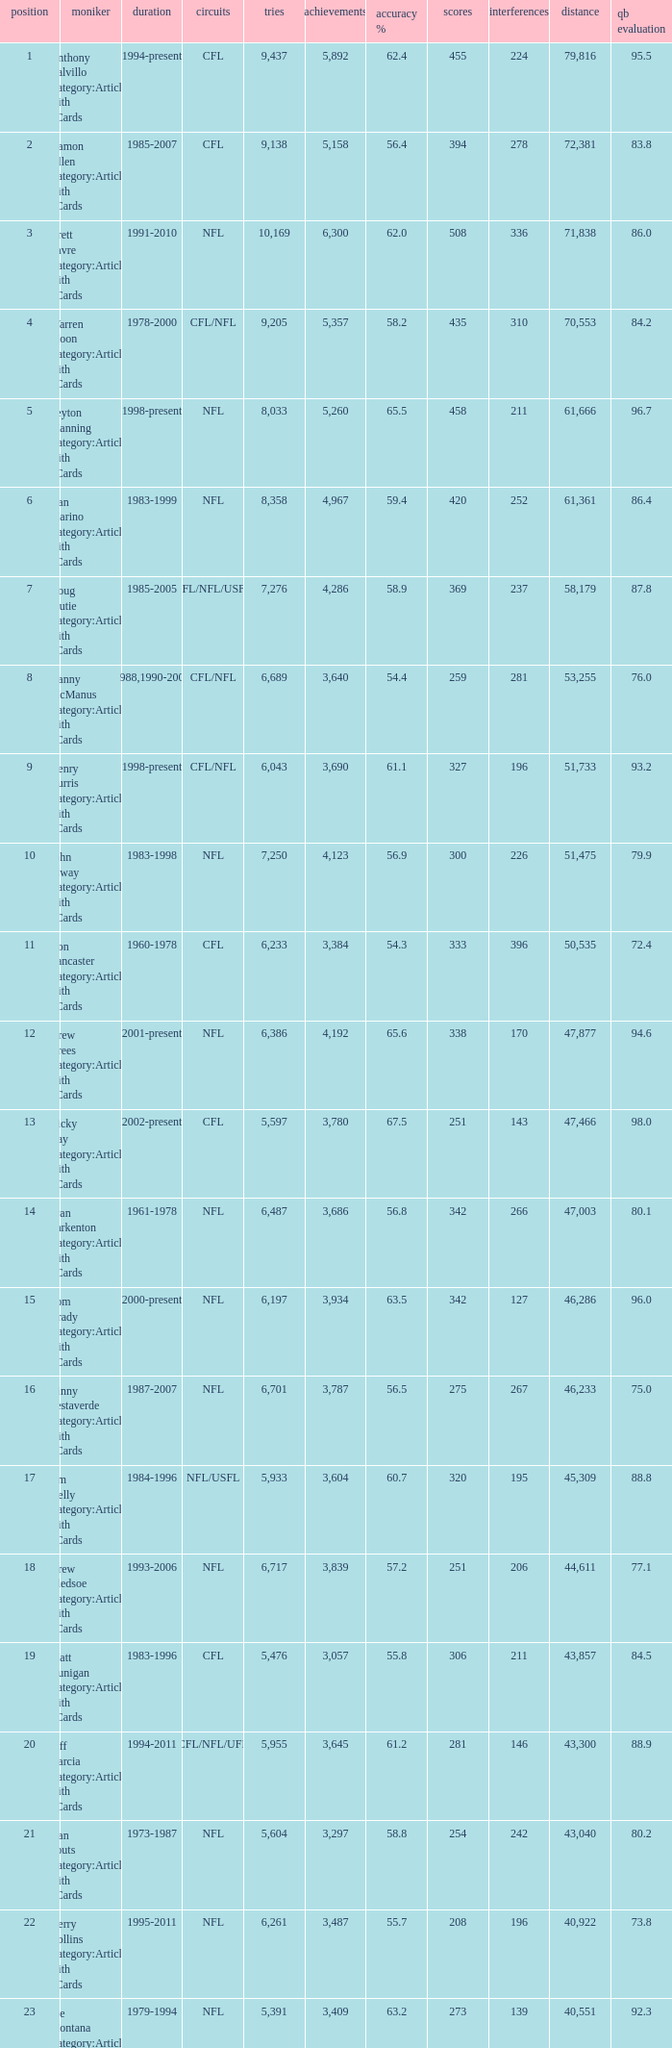What is the comp percentage when there are less than 44,611 in yardage, more than 254 touchdowns, and rank larger than 24? 54.6. 